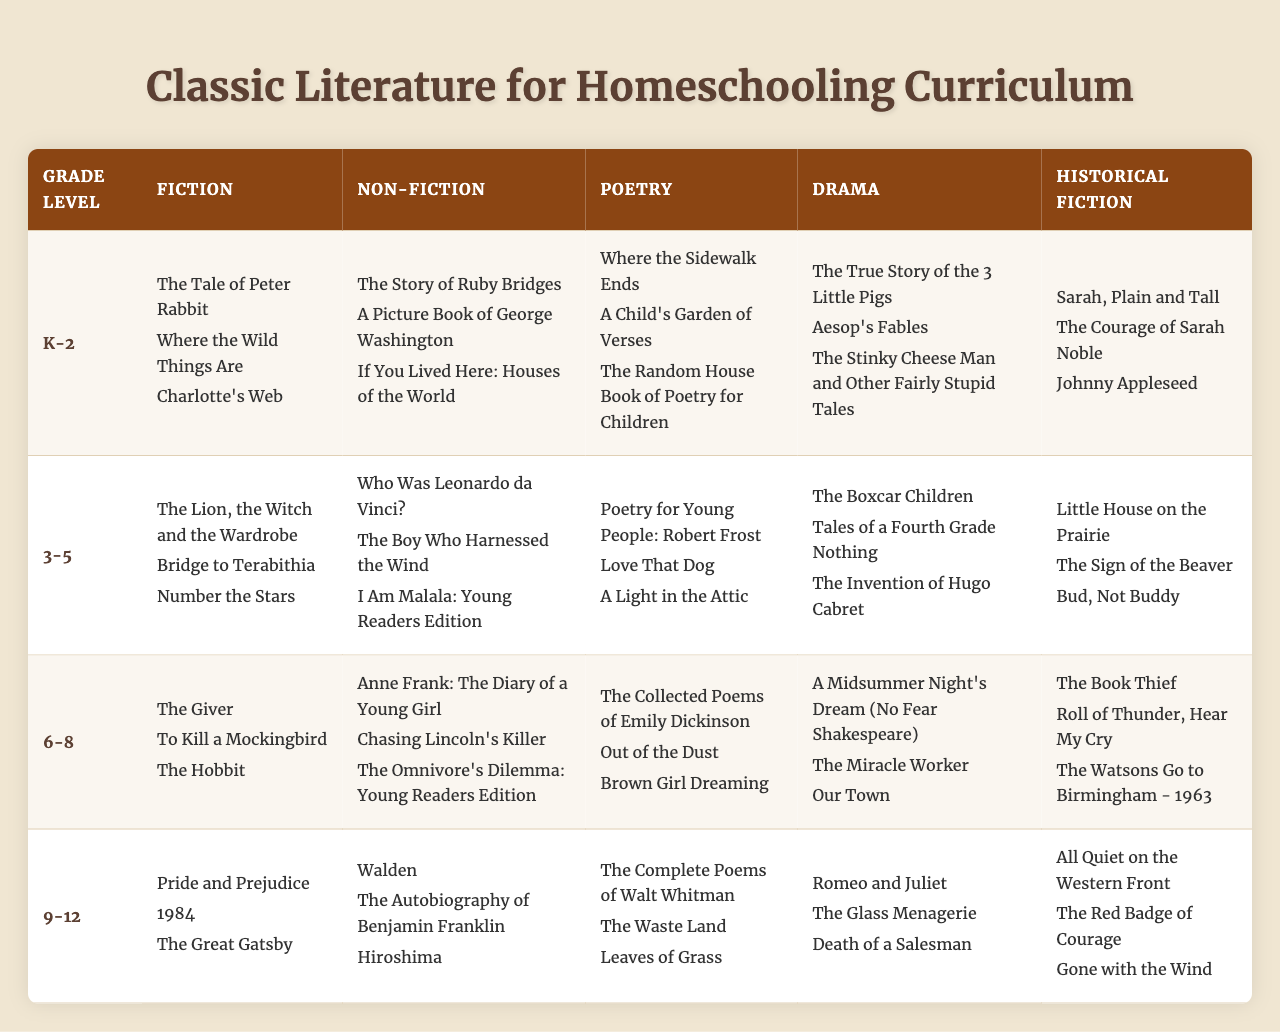What grade level has the most fiction titles listed? The grade levels with fiction titles are K-2, 3-5, 6-8, and 9-12. Each grade level has three fiction titles listed, so they all have the same amount.
Answer: All grade levels have three titles Which poetry book is listed for grades 3-5? The poetry titles for grades 3-5 include "Poetry for Young People: Robert Frost," "Love That Dog," and "A Light in the Attic." The first one is the requested title.
Answer: "Poetry for Young People: Robert Frost." Is "1984" included in the Non-Fiction category? "1984" is listed under the Fiction category for grade 9-12, not the Non-Fiction category.
Answer: No How many Historical Fiction titles are listed for grade 6-8? The Historical Fiction titles listed for grade 6-8 are "The Book Thief," "Roll of Thunder, Hear My Cry," and "The Watsons Go to Birmingham - 1963," which totals three titles.
Answer: Three titles Which category has the most titles listed for grades K-2? For grades K-2, the Fiction, Non-Fiction, Poetry, Drama, and Historical Fiction categories each have three titles listed, indicating they all tie for the most.
Answer: All categories have three titles Are there any Drama titles in grade 9-12? The Drama titles for grade 9-12 include "Romeo and Juliet," "The Glass Menagerie," and "Death of a Salesman," confirming that there are Drama titles for this grade level.
Answer: Yes What is the total number of Fiction titles across all grade levels? Each of the four grade levels has three Fiction titles, so the total is calculated as 3 (titles per grade) * 4 (grades) = 12 titles.
Answer: 12 titles Which grade level features "The Omnivore's Dilemma: Young Readers Edition"? "The Omnivore's Dilemma: Young Readers Edition" is listed under Non-Fiction for grade 6-8.
Answer: Grade 6-8 Which two titles are the first listed under Fiction for grade 3-5? The first two titles under Fiction for grade 3-5 are "The Lion, the Witch and the Wardrobe" and "Bridge to Terabithia."
Answer: "The Lion, the Witch and the Wardrobe" and "Bridge to Terabithia." Is there any overlap in titles listed between the Fiction and Drama categories for grade 6-8? Comparing the titles, "A Midsummer Night's Dream" (Drama) is different from the Fiction titles "The Giver," "To Kill a Mockingbird," and "The Hobbit," indicating no overlap.
Answer: No 